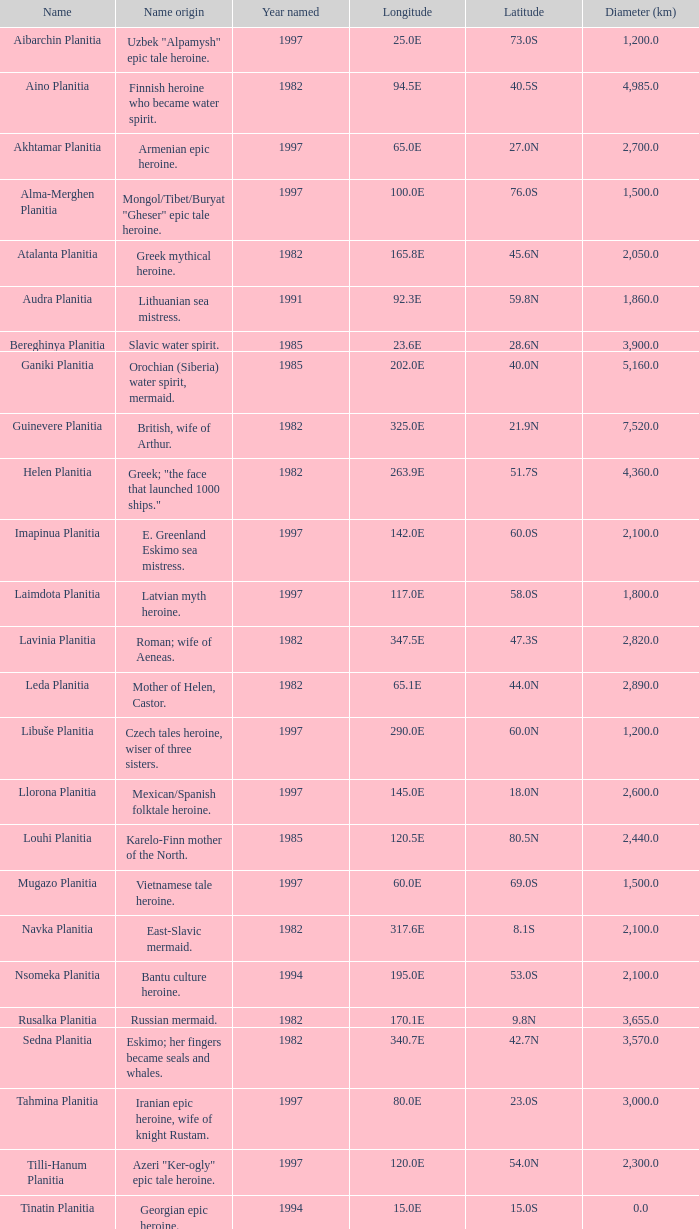What is the latitude of the feature of longitude 80.0e 23.0S. 